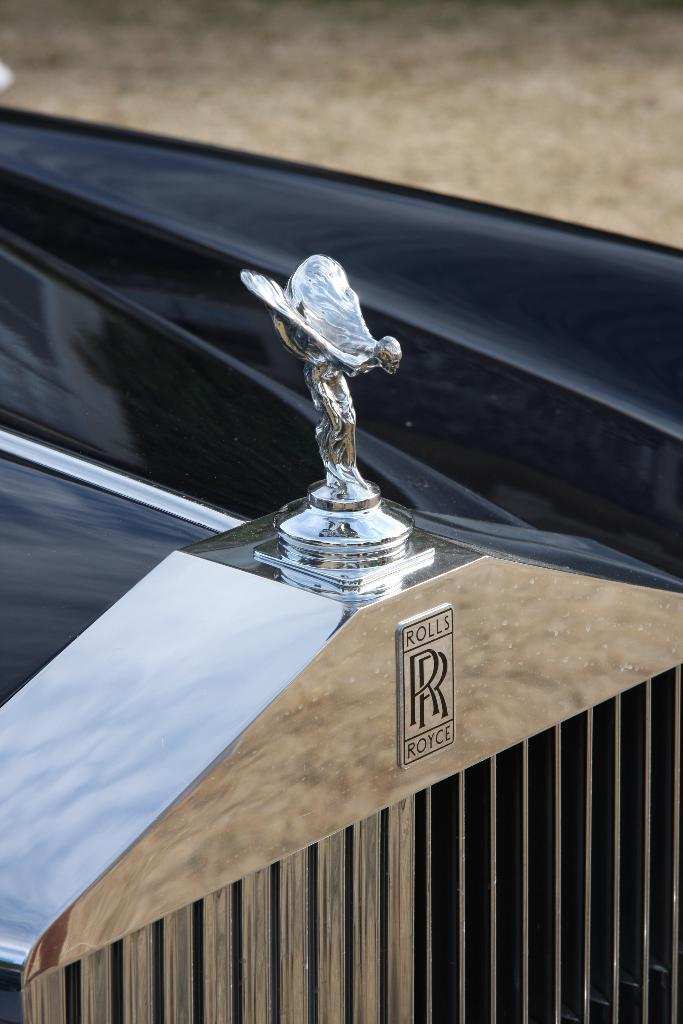What is on top of the car in the image? There is a small statue on the car. What can be seen on the car that might indicate its brand or model? There is a brand logo visible on the car. What type of vehicle is depicted in the image? The object in the image is a car. What channel is the car tuned to in the image? There is no indication of a channel or any form of media consumption in the image; it simply shows a car with a small statue and a brand logo. What authority figure is depicted in the image? There is no authority figure present in the image; it features a car with a small statue and a brand logo. 